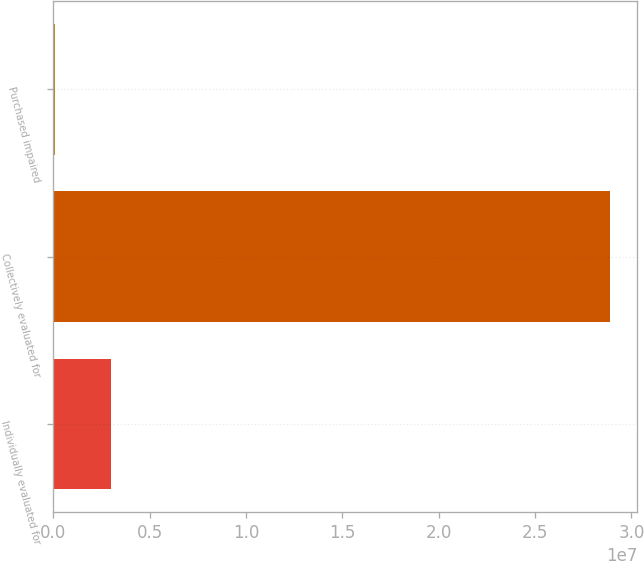<chart> <loc_0><loc_0><loc_500><loc_500><bar_chart><fcel>Individually evaluated for<fcel>Collectively evaluated for<fcel>Purchased impaired<nl><fcel>2.97636e+06<fcel>2.88631e+07<fcel>100049<nl></chart> 